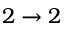<formula> <loc_0><loc_0><loc_500><loc_500>2 \rightarrow 2</formula> 